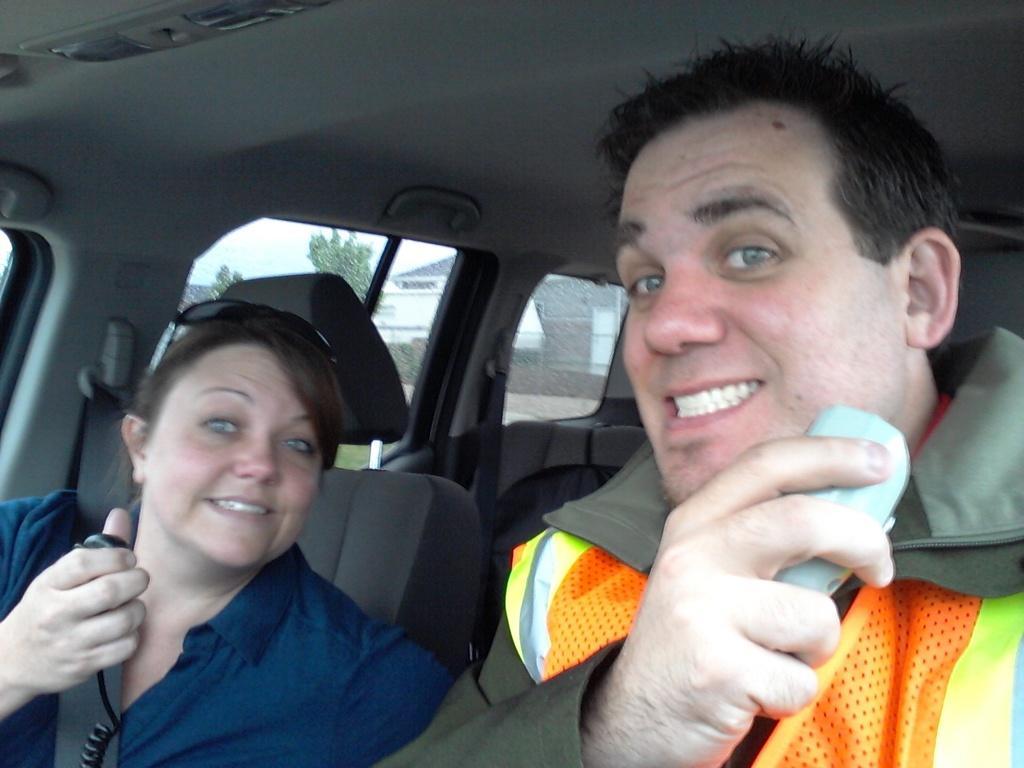In one or two sentences, can you explain what this image depicts? In this image I can see two people sitting inside the car. Outside there are trees and the sky. 